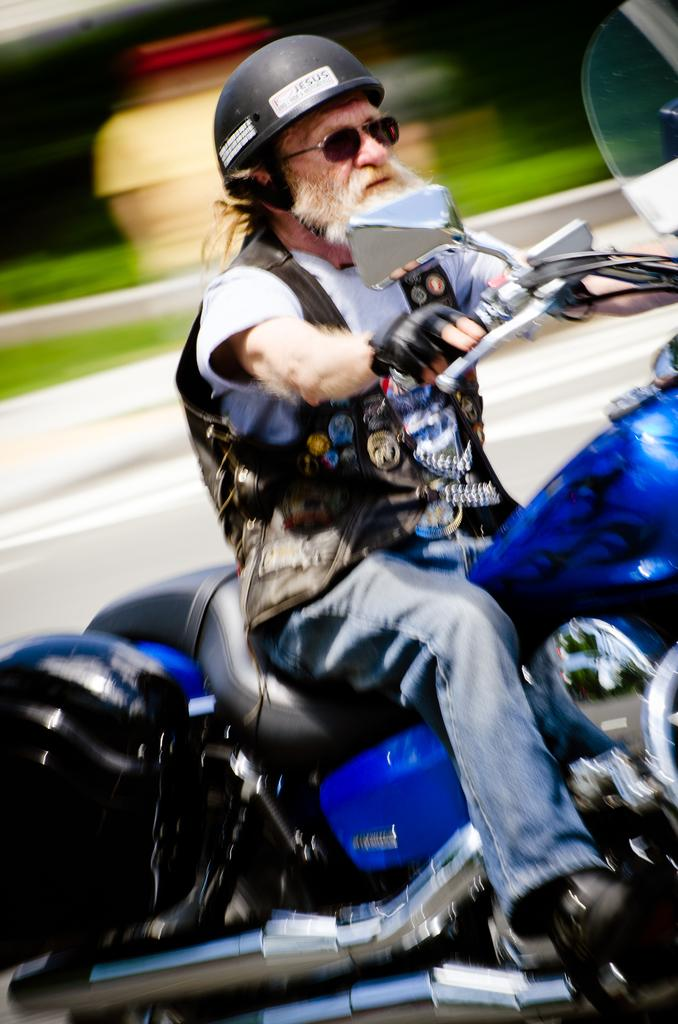What is the person in the image doing? The person in the image is riding a motorcycle. What color is the motorcycle? The motorcycle is blue. What protective gear is the person wearing? The person is wearing goggles, a helmet, black gloves, a white t-shirt, and jeans. What is visible behind the motorcycle? There is a road behind the motorcycle. What type of vegetation can be seen in the image? There is grass visible in the image. How many hydrants are visible in the image? There are no hydrants visible in the image. What type of potato is the person holding while riding the motorcycle? There is no potato present in the image; the person is wearing gloves and riding a motorcycle. 